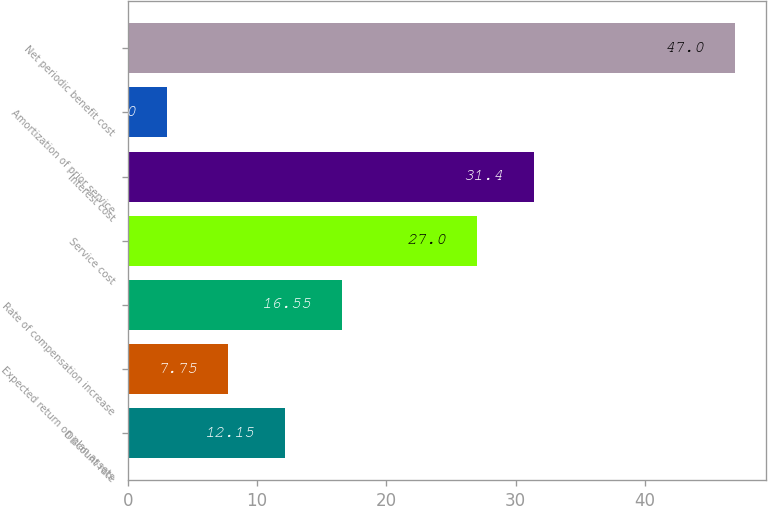Convert chart. <chart><loc_0><loc_0><loc_500><loc_500><bar_chart><fcel>Discount rate<fcel>Expected return on plan assets<fcel>Rate of compensation increase<fcel>Service cost<fcel>Interest cost<fcel>Amortization of prior service<fcel>Net periodic benefit cost<nl><fcel>12.15<fcel>7.75<fcel>16.55<fcel>27<fcel>31.4<fcel>3<fcel>47<nl></chart> 